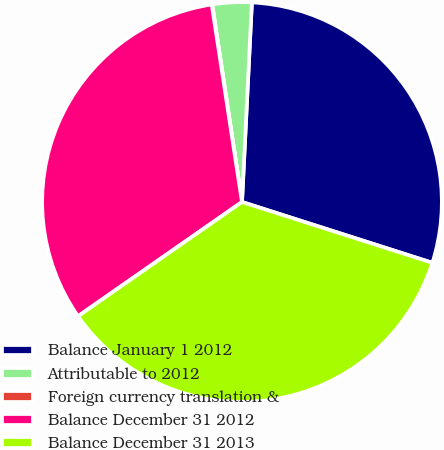<chart> <loc_0><loc_0><loc_500><loc_500><pie_chart><fcel>Balance January 1 2012<fcel>Attributable to 2012<fcel>Foreign currency translation &<fcel>Balance December 31 2012<fcel>Balance December 31 2013<nl><fcel>29.14%<fcel>3.17%<fcel>0.04%<fcel>32.27%<fcel>35.4%<nl></chart> 